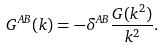<formula> <loc_0><loc_0><loc_500><loc_500>G ^ { A B } ( k ) = - \delta ^ { A B } \frac { G ( k ^ { 2 } ) } { k ^ { 2 } } .</formula> 